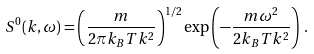<formula> <loc_0><loc_0><loc_500><loc_500>S ^ { 0 } ( k , \omega ) = \left ( \frac { m } { 2 \pi k _ { B } T k ^ { 2 } } \right ) ^ { 1 / 2 } \exp \left ( - \frac { m \omega ^ { 2 } } { 2 k _ { B } T k ^ { 2 } } \right ) \, .</formula> 